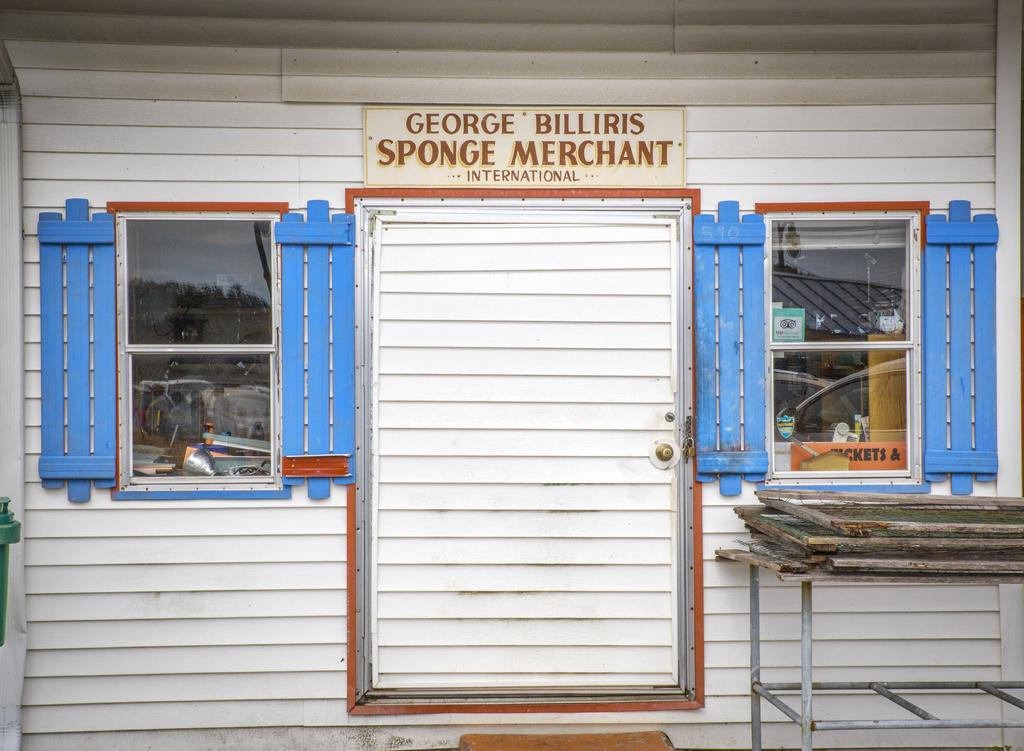What type of establishment is depicted in the image? The image appears to depict a shop. Can you identify any specific features of the shop? There is a door and two windows visible in the image. What material are the frames of the windows and door made of? The frames are made of wood, as wooden frames are visible in the image. Is there any text present in the image? Yes, there is text at the top of the image. How many people are taking a bath in the image? There are no people taking a bath in the image, as it depicts a shop with a door, windows, and wooden frames. What type of gate is present in the image? There is no gate present in the image; it depicts a shop with a door, windows, and wooden frames. 